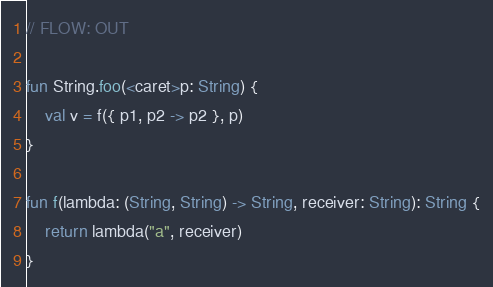Convert code to text. <code><loc_0><loc_0><loc_500><loc_500><_Kotlin_>// FLOW: OUT

fun String.foo(<caret>p: String) {
    val v = f({ p1, p2 -> p2 }, p)
}

fun f(lambda: (String, String) -> String, receiver: String): String {
    return lambda("a", receiver)
}
</code> 